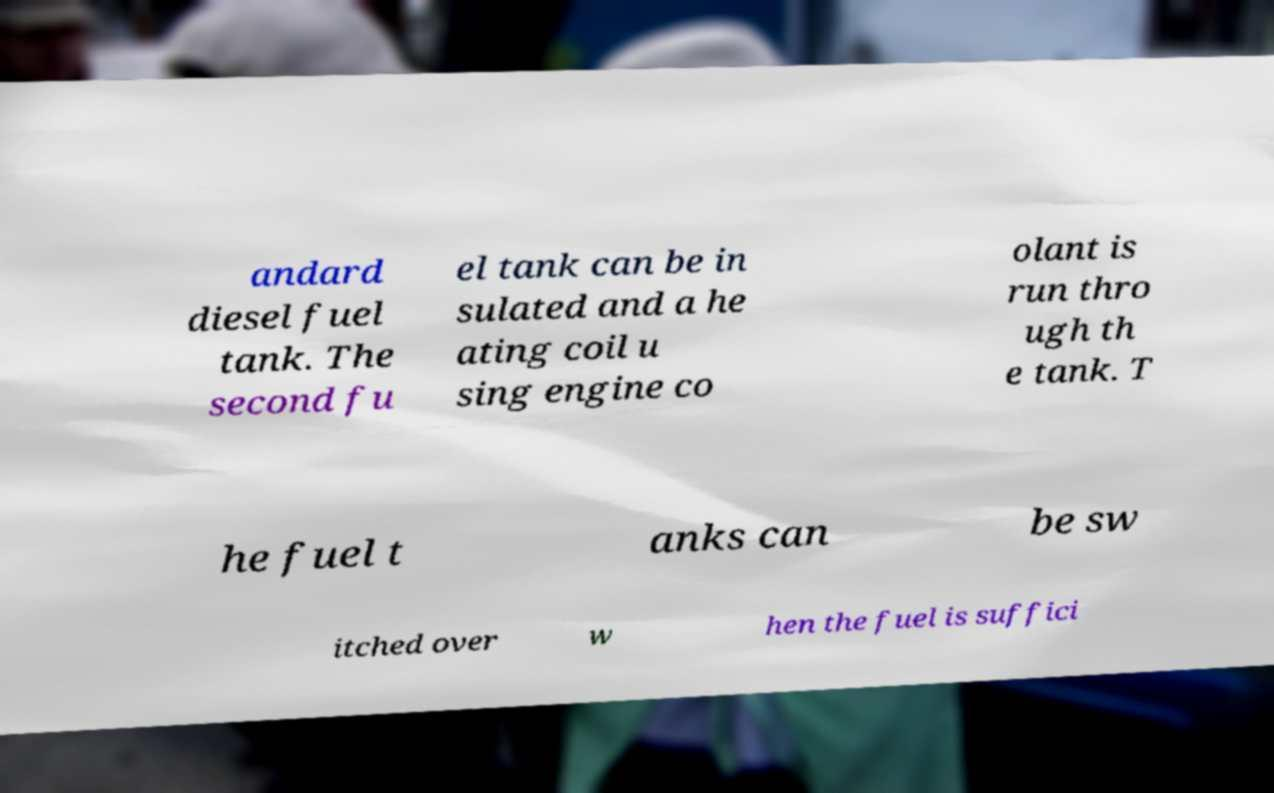Could you extract and type out the text from this image? andard diesel fuel tank. The second fu el tank can be in sulated and a he ating coil u sing engine co olant is run thro ugh th e tank. T he fuel t anks can be sw itched over w hen the fuel is suffici 